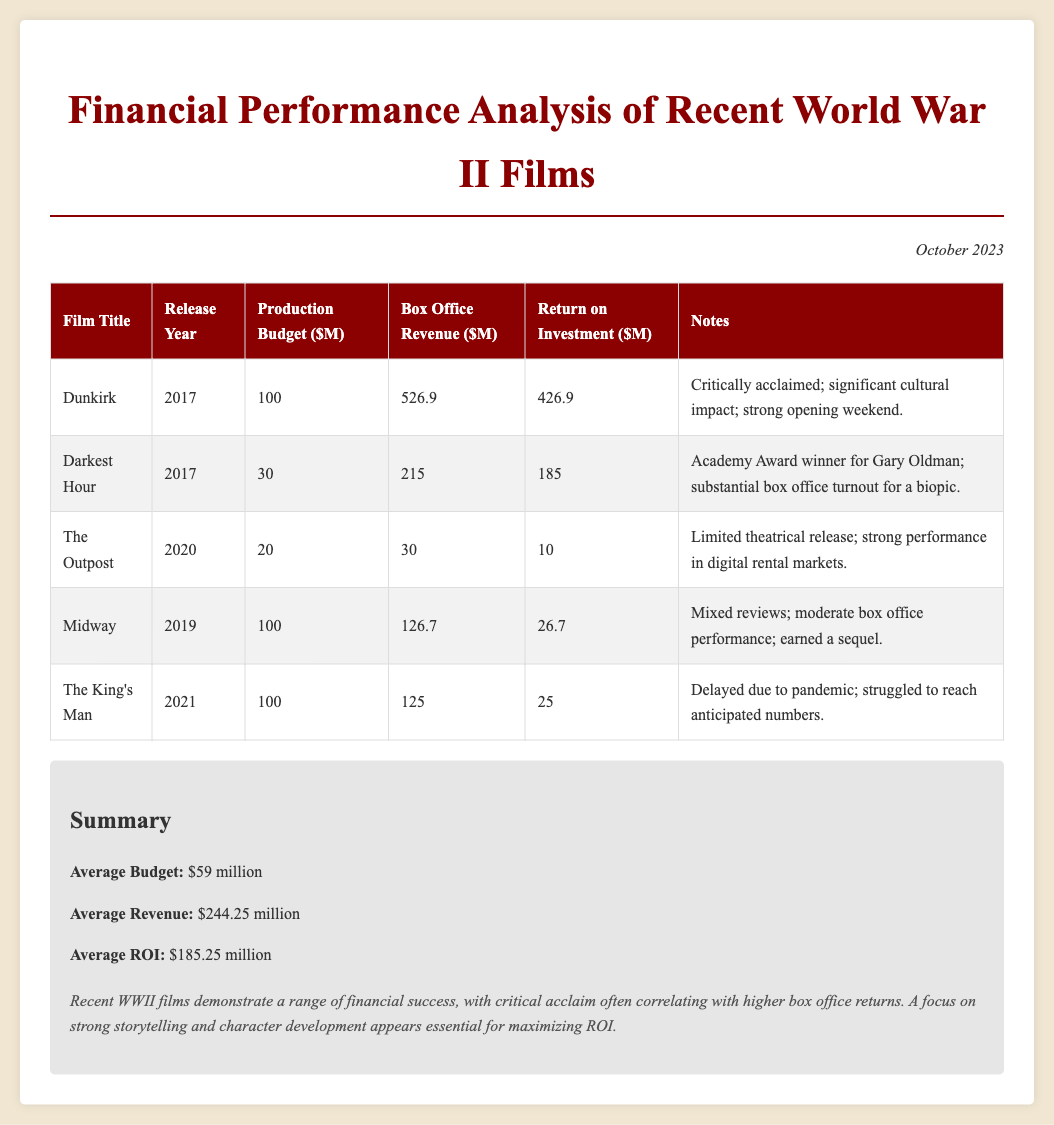What is the production budget of Dunkirk? The production budget of Dunkirk is listed in the table as $100 million.
Answer: $100 million What is the box office revenue for Darkest Hour? The box office revenue for Darkest Hour can be found in the table, which indicates it is $215 million.
Answer: $215 million What year was The Outpost released? The release year of The Outpost is provided in the document as 2020.
Answer: 2020 What is the average budget of the films listed? The average budget is calculated in the summary section of the document, which states it is $59 million.
Answer: $59 million Which film had the highest return on investment? The return on investment for Dunkirk is $426.9 million, which is the highest among the films.
Answer: Dunkirk How much did Midway earn in box office revenue? The box office revenue for Midway is detailed in the table as $126.7 million.
Answer: $126.7 million How many films listed had a box office revenue less than their production budget? The table shows that The Outpost, Midway, and The King's Man had box office revenues less than their respective production budgets, totaling 3 films.
Answer: 3 films What is the conclusion about recent WWII films? The conclusion in the document highlights that recent WWII films show a range of financial success with critical acclaim sometimes correlating with higher box office returns.
Answer: Critical acclaim correlates with higher box office returns What notable achievement did Darkest Hour have? Darkest Hour was noted for winning an Academy Award for Gary Oldman, as mentioned in the notes column.
Answer: Academy Award winner for Gary Oldman 